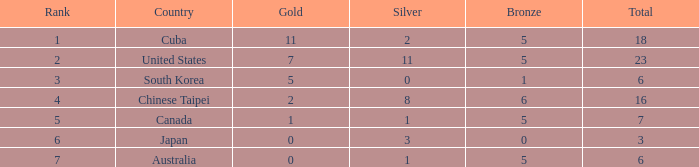What is the lowest total medals for the united states who had more than 11 silver medals? None. 